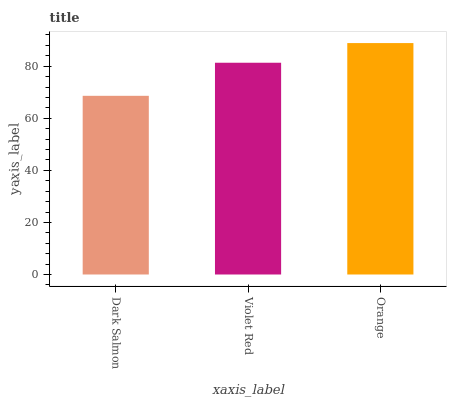Is Dark Salmon the minimum?
Answer yes or no. Yes. Is Orange the maximum?
Answer yes or no. Yes. Is Violet Red the minimum?
Answer yes or no. No. Is Violet Red the maximum?
Answer yes or no. No. Is Violet Red greater than Dark Salmon?
Answer yes or no. Yes. Is Dark Salmon less than Violet Red?
Answer yes or no. Yes. Is Dark Salmon greater than Violet Red?
Answer yes or no. No. Is Violet Red less than Dark Salmon?
Answer yes or no. No. Is Violet Red the high median?
Answer yes or no. Yes. Is Violet Red the low median?
Answer yes or no. Yes. Is Orange the high median?
Answer yes or no. No. Is Dark Salmon the low median?
Answer yes or no. No. 